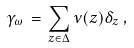Convert formula to latex. <formula><loc_0><loc_0><loc_500><loc_500>\gamma _ { \omega } \, = \, \sum _ { z \in \Delta } \nu ( z ) \delta _ { z } \, ,</formula> 